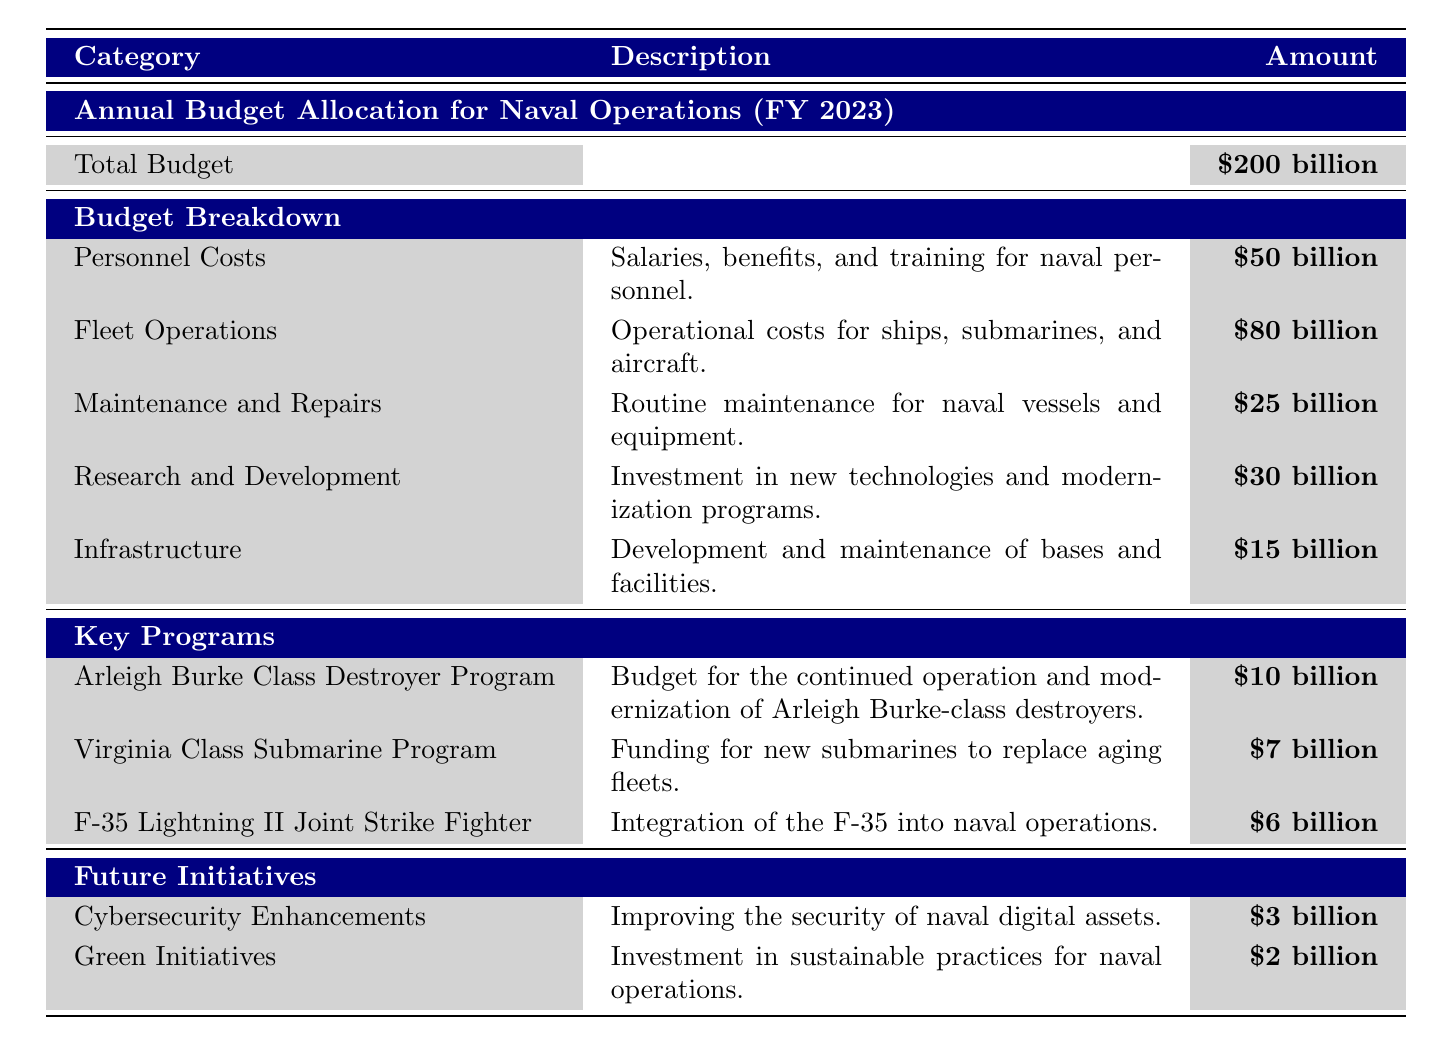What is the total budget allocated for naval operations in FY 2023? The total budget for naval operations for the fiscal year 2023 is listed clearly in the table under "Total Budget."
Answer: $200 billion What is the amount allocated for Fleet Operations? The amount for Fleet Operations is provided directly under the "Budget Breakdown" section, which indicates it is $80 billion.
Answer: $80 billion How much funding is allocated for Maintenance and Repairs? The table specifies the amount for Maintenance and Repairs as $25 billion in the Budget Breakdown.
Answer: $25 billion What is the total funding for key naval programs listed? To find the total funding, we add the allocations for all key programs: $10 billion (Arleigh Burke Class Destroyer Program) + $7 billion (Virginia Class Submarine Program) + $6 billion (F-35 Lightning II Joint Strike Fighter) = $23 billion.
Answer: $23 billion Is there a budget allocated for Cybersecurity Enhancements? Yes, the table indicates a proposed budget of $3 billion for Cybersecurity Enhancements under the Future Initiatives section.
Answer: Yes What is the difference between the total budget for Research and Development and the proposed budget for Green Initiatives? The total budget for Research and Development is $30 billion, and the proposed budget for Green Initiatives is $2 billion. The difference is $30 billion - $2 billion = $28 billion.
Answer: $28 billion What percentage of the total budget is allocated to Personnel Costs? To find the percentage, we divide the amount for Personnel Costs ($50 billion) by the total budget ($200 billion) and then multiply by 100. Thus, ($50 billion / $200 billion) * 100 = 25%.
Answer: 25% If the funding for Green Initiatives increases by $1 billion, what would be the new proposed budget for it? The original proposed budget for Green Initiatives is $2 billion. Adding $1 billion would give us $2 billion + $1 billion = $3 billion.
Answer: $3 billion Which budget category has the highest allocation, and how does it compare to the second highest? The category with the highest allocation is Fleet Operations at $80 billion. The second highest is Personnel Costs at $50 billion. The difference is $80 billion - $50 billion = $30 billion.
Answer: Fleet Operations: $80 billion; difference: $30 billion What is the total budget for maintenance-related initiatives (Maintenance and Repairs and Research and Development)? The total for maintenance-related initiatives includes Maintenance and Repairs ($25 billion) and Research and Development ($30 billion). Adding these gives $25 billion + $30 billion = $55 billion.
Answer: $55 billion 